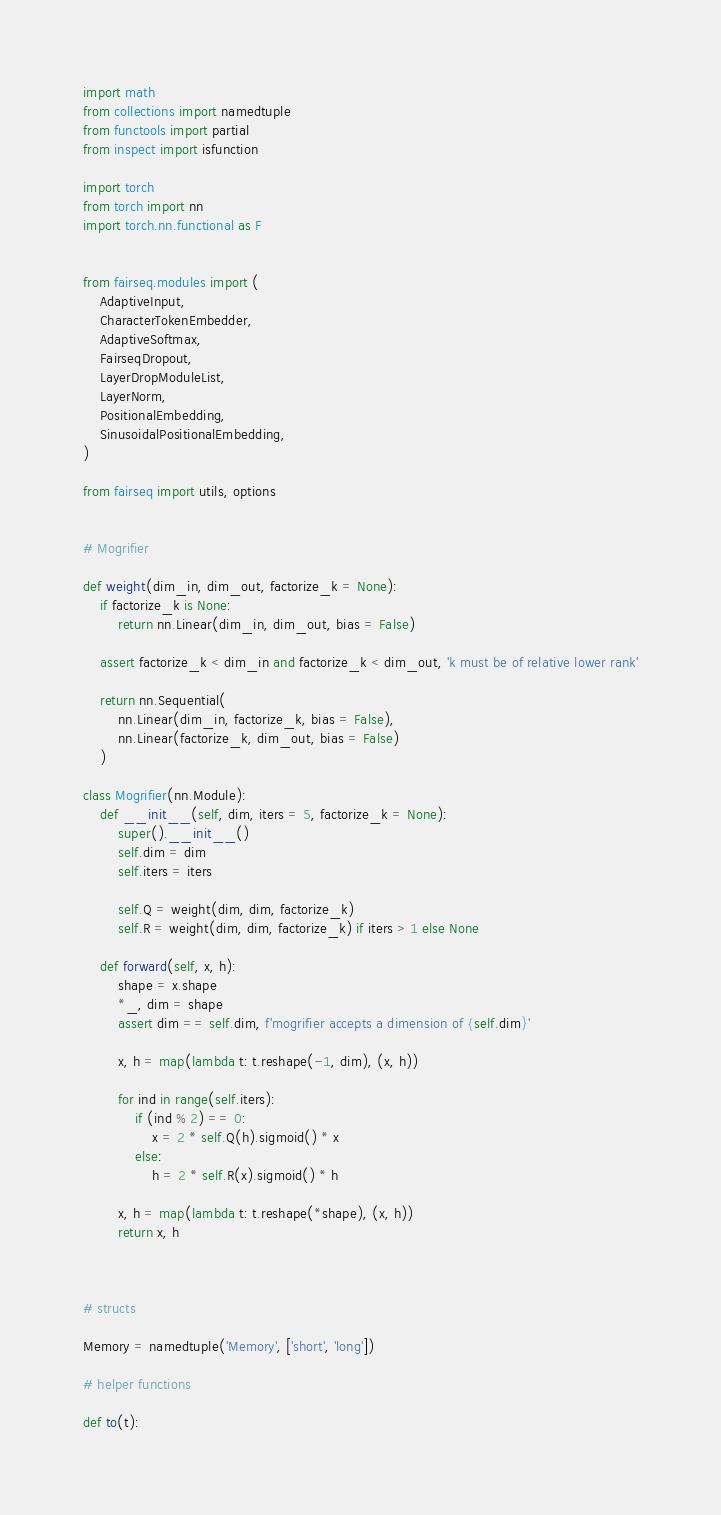Convert code to text. <code><loc_0><loc_0><loc_500><loc_500><_Python_>import math
from collections import namedtuple
from functools import partial
from inspect import isfunction

import torch
from torch import nn
import torch.nn.functional as F


from fairseq.modules import (
    AdaptiveInput,
    CharacterTokenEmbedder,
    AdaptiveSoftmax,
    FairseqDropout,
    LayerDropModuleList,
    LayerNorm,
    PositionalEmbedding,
    SinusoidalPositionalEmbedding,
)

from fairseq import utils, options


# Mogrifier

def weight(dim_in, dim_out, factorize_k = None):
    if factorize_k is None:
        return nn.Linear(dim_in, dim_out, bias = False)

    assert factorize_k < dim_in and factorize_k < dim_out, 'k must be of relative lower rank'

    return nn.Sequential(
        nn.Linear(dim_in, factorize_k, bias = False),
        nn.Linear(factorize_k, dim_out, bias = False)
    )

class Mogrifier(nn.Module):
    def __init__(self, dim, iters = 5, factorize_k = None):
        super().__init__()
        self.dim = dim
        self.iters = iters

        self.Q = weight(dim, dim, factorize_k)
        self.R = weight(dim, dim, factorize_k) if iters > 1 else None

    def forward(self, x, h):
        shape = x.shape
        *_, dim = shape
        assert dim == self.dim, f'mogrifier accepts a dimension of {self.dim}'

        x, h = map(lambda t: t.reshape(-1, dim), (x, h))

        for ind in range(self.iters):
            if (ind % 2) == 0:
                x = 2 * self.Q(h).sigmoid() * x
            else:
                h = 2 * self.R(x).sigmoid() * h

        x, h = map(lambda t: t.reshape(*shape), (x, h))
        return x, h



# structs

Memory = namedtuple('Memory', ['short', 'long'])

# helper functions

def to(t):</code> 